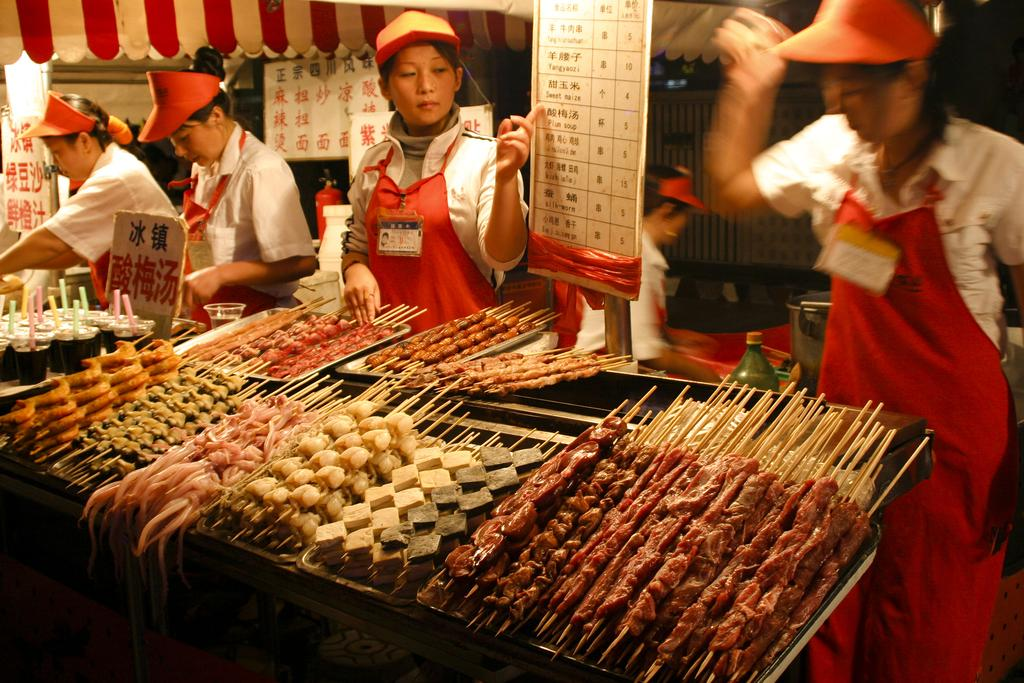What can be observed about the people in the image? There are people standing in the image, and they are wearing the same costume and caps. What might be used to identify the people in the image? The people have identity cards. What else is present in the image besides the people? There are food items and a board in the image. What can be read on the board in the image? There is text on the board. What type of slope can be seen in the image? There is no slope present in the image. Who is the minister in the image? There is no minister present in the image. 